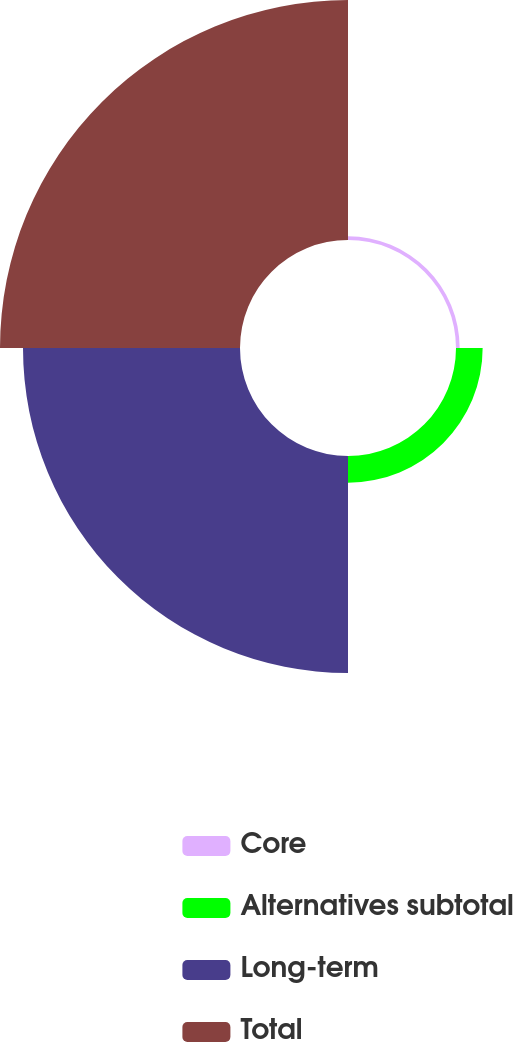Convert chart to OTSL. <chart><loc_0><loc_0><loc_500><loc_500><pie_chart><fcel>Core<fcel>Alternatives subtotal<fcel>Long-term<fcel>Total<nl><fcel>0.75%<fcel>5.47%<fcel>44.53%<fcel>49.25%<nl></chart> 